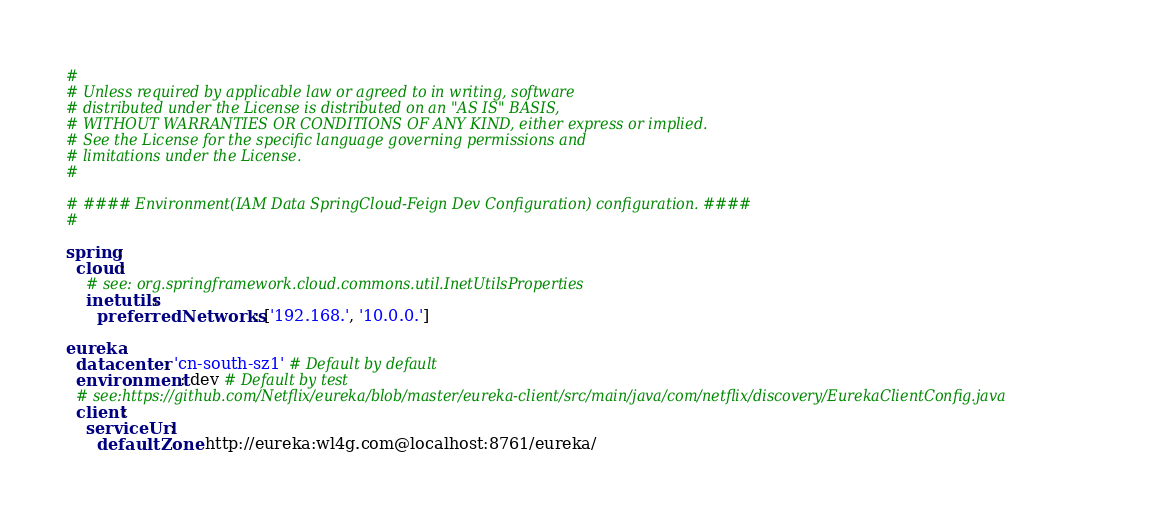<code> <loc_0><loc_0><loc_500><loc_500><_YAML_>#
# Unless required by applicable law or agreed to in writing, software
# distributed under the License is distributed on an "AS IS" BASIS,
# WITHOUT WARRANTIES OR CONDITIONS OF ANY KIND, either express or implied.
# See the License for the specific language governing permissions and
# limitations under the License.
#

# #### Environment(IAM Data SpringCloud-Feign Dev Configuration) configuration. ####
#

spring:
  cloud:
    # see: org.springframework.cloud.commons.util.InetUtilsProperties
    inetutils:
      preferredNetworks: ['192.168.', '10.0.0.']

eureka:
  datacenter: 'cn-south-sz1' # Default by default
  environment: dev # Default by test
  # see:https://github.com/Netflix/eureka/blob/master/eureka-client/src/main/java/com/netflix/discovery/EurekaClientConfig.java
  client:
    serviceUrl:
      defaultZone: http://eureka:wl4g.com@localhost:8761/eureka/
</code> 